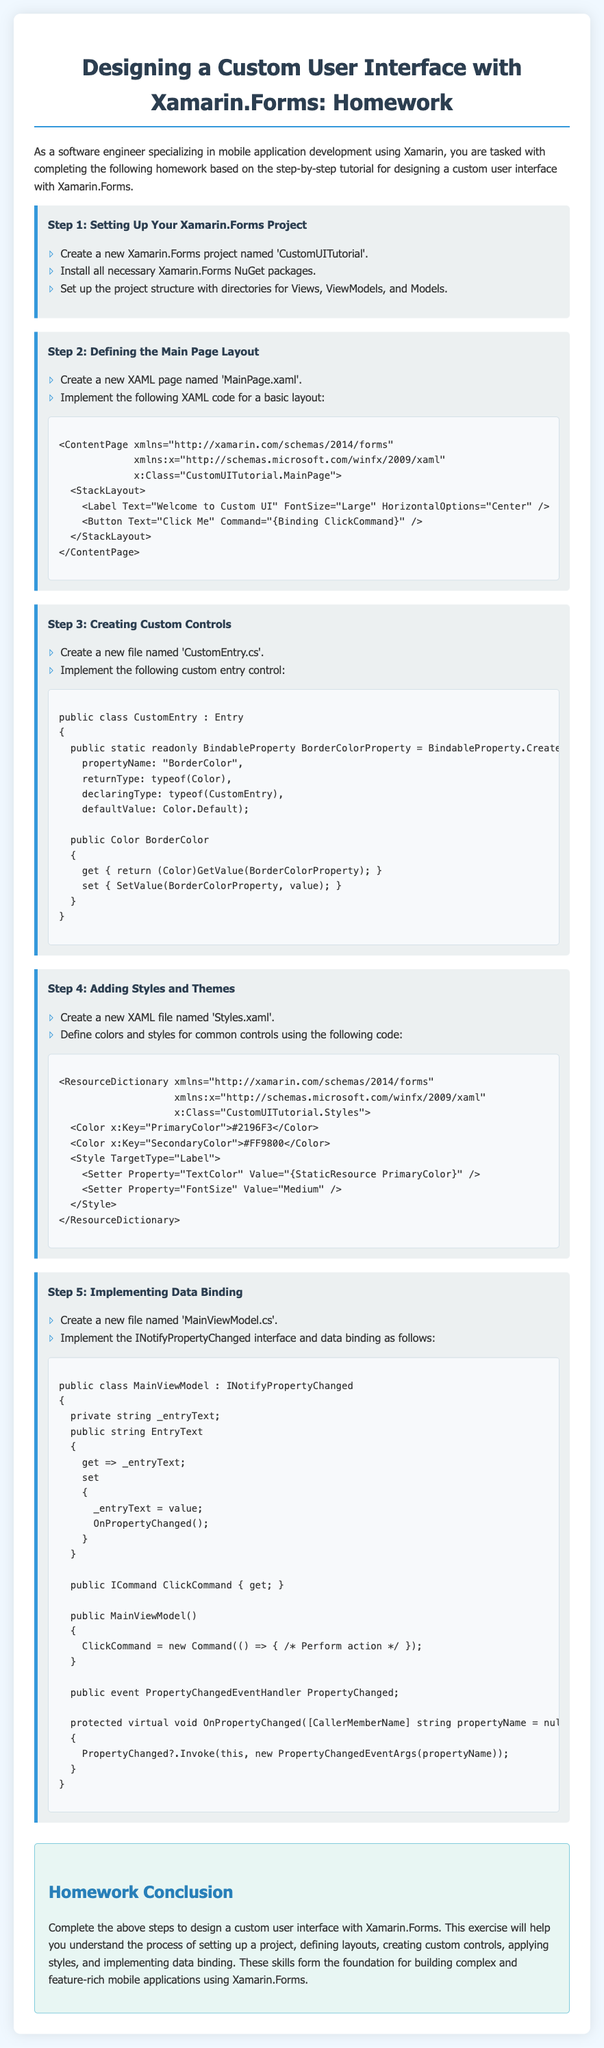What is the title of the homework document? The title is mentioned in the heading of the document.
Answer: Designing a Custom User Interface with Xamarin.Forms: Homework How many main steps are outlined in the homework? The main steps are numbered in the document; there are five steps provided.
Answer: 5 What command is bound to the button in the XAML code? The XAML code shows the command binding syntax.
Answer: ClickCommand What color is defined as the primary color in the styles? The colors and their values are listed under the styles section.
Answer: #2196F3 Which interface must be implemented for data binding in the ViewModel? The document specifically states the need for a property change interface.
Answer: INotifyPropertyChanged What component of the UI does 'CustomEntry' extend? The document specifies that 'CustomEntry' is derived from a specific base component.
Answer: Entry What is the name of the XAML file for the main page? The document explicitly mentions the file name for the main page layout.
Answer: MainPage.xaml What is the purpose of the 'OnPropertyChanged' method? The purpose is stated in the context of property changes in the ViewModel.
Answer: Notify property change What is the main focus of this homework assignment? The document outlines the objectives regarding UI design and related features.
Answer: Custom user interface design 